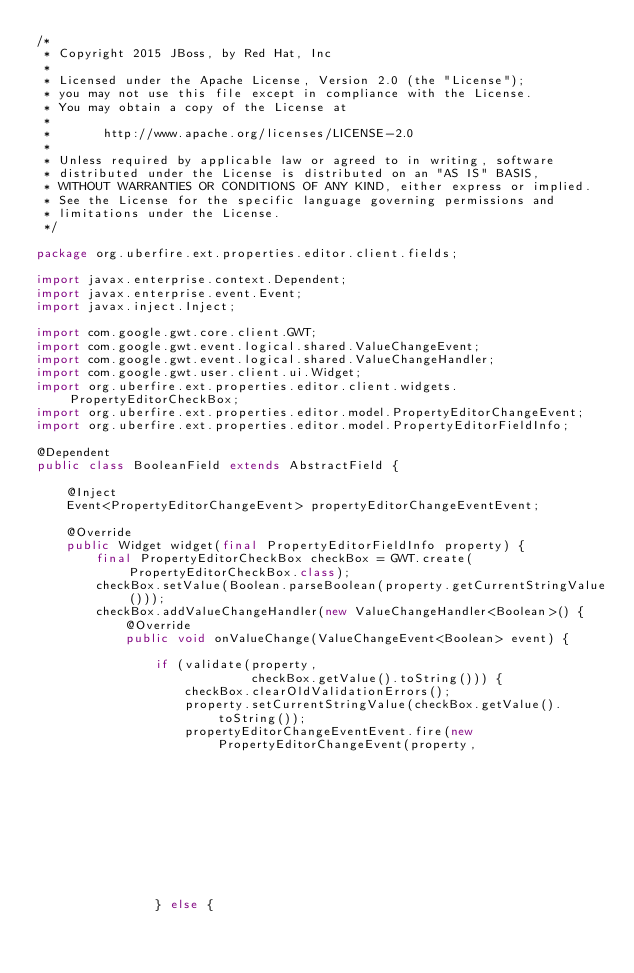Convert code to text. <code><loc_0><loc_0><loc_500><loc_500><_Java_>/*
 * Copyright 2015 JBoss, by Red Hat, Inc
 *
 * Licensed under the Apache License, Version 2.0 (the "License");
 * you may not use this file except in compliance with the License.
 * You may obtain a copy of the License at
 *
 *       http://www.apache.org/licenses/LICENSE-2.0
 *
 * Unless required by applicable law or agreed to in writing, software
 * distributed under the License is distributed on an "AS IS" BASIS,
 * WITHOUT WARRANTIES OR CONDITIONS OF ANY KIND, either express or implied.
 * See the License for the specific language governing permissions and
 * limitations under the License.
 */

package org.uberfire.ext.properties.editor.client.fields;

import javax.enterprise.context.Dependent;
import javax.enterprise.event.Event;
import javax.inject.Inject;

import com.google.gwt.core.client.GWT;
import com.google.gwt.event.logical.shared.ValueChangeEvent;
import com.google.gwt.event.logical.shared.ValueChangeHandler;
import com.google.gwt.user.client.ui.Widget;
import org.uberfire.ext.properties.editor.client.widgets.PropertyEditorCheckBox;
import org.uberfire.ext.properties.editor.model.PropertyEditorChangeEvent;
import org.uberfire.ext.properties.editor.model.PropertyEditorFieldInfo;

@Dependent
public class BooleanField extends AbstractField {

    @Inject
    Event<PropertyEditorChangeEvent> propertyEditorChangeEventEvent;

    @Override
    public Widget widget(final PropertyEditorFieldInfo property) {
        final PropertyEditorCheckBox checkBox = GWT.create(PropertyEditorCheckBox.class);
        checkBox.setValue(Boolean.parseBoolean(property.getCurrentStringValue()));
        checkBox.addValueChangeHandler(new ValueChangeHandler<Boolean>() {
            @Override
            public void onValueChange(ValueChangeEvent<Boolean> event) {

                if (validate(property,
                             checkBox.getValue().toString())) {
                    checkBox.clearOldValidationErrors();
                    property.setCurrentStringValue(checkBox.getValue().toString());
                    propertyEditorChangeEventEvent.fire(new PropertyEditorChangeEvent(property,
                                                                                      checkBox.getValue().toString()));
                } else {</code> 